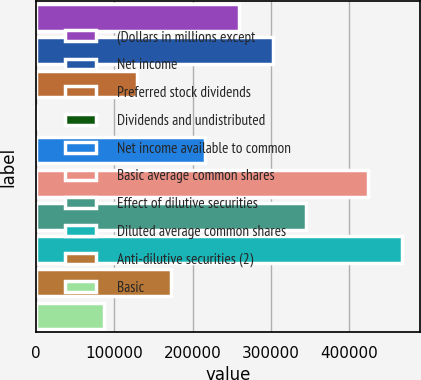Convert chart. <chart><loc_0><loc_0><loc_500><loc_500><bar_chart><fcel>(Dollars in millions except<fcel>Net income<fcel>Preferred stock dividends<fcel>Dividends and undistributed<fcel>Net income available to common<fcel>Basic average common shares<fcel>Effect of dilutive securities<fcel>Diluted average common shares<fcel>Anti-dilutive securities (2)<fcel>Basic<nl><fcel>259205<fcel>302406<fcel>129604<fcel>3<fcel>216005<fcel>424223<fcel>345606<fcel>467423<fcel>172805<fcel>86403.8<nl></chart> 